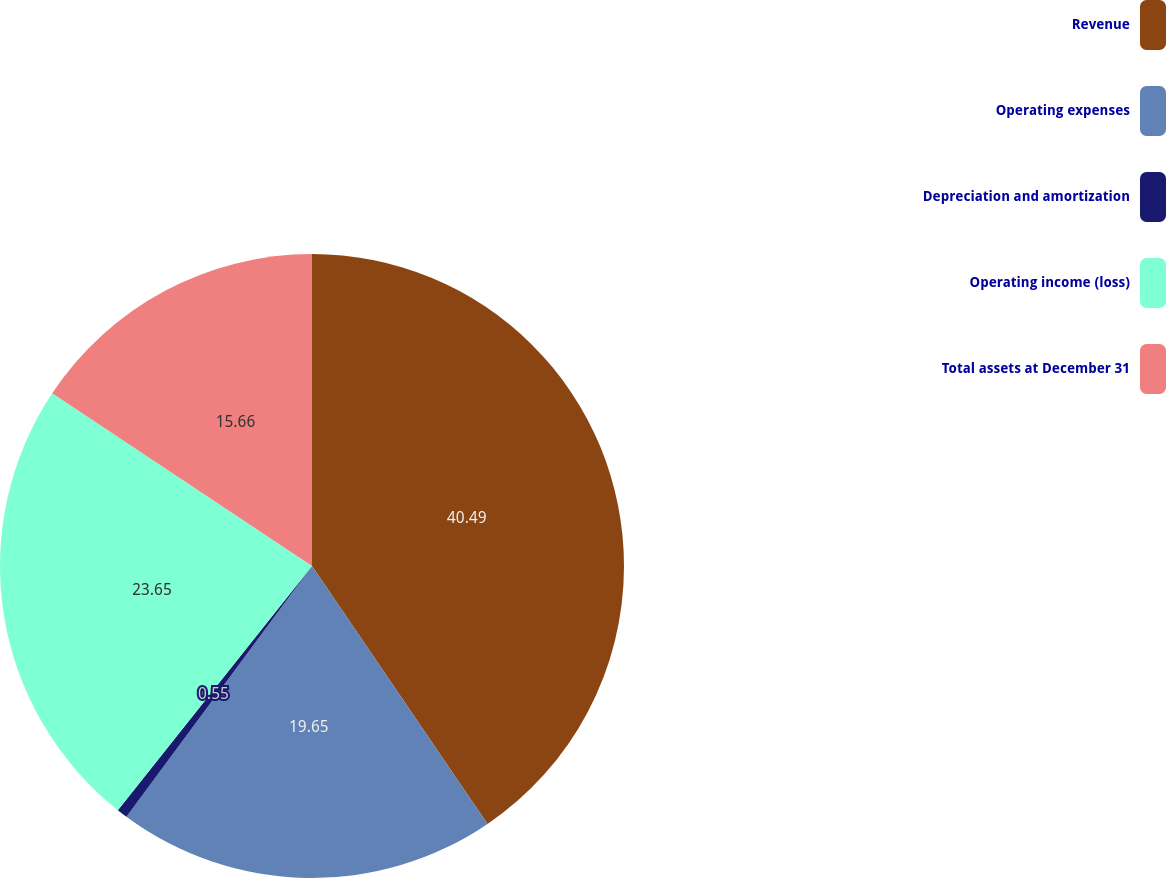Convert chart to OTSL. <chart><loc_0><loc_0><loc_500><loc_500><pie_chart><fcel>Revenue<fcel>Operating expenses<fcel>Depreciation and amortization<fcel>Operating income (loss)<fcel>Total assets at December 31<nl><fcel>40.49%<fcel>19.65%<fcel>0.55%<fcel>23.65%<fcel>15.66%<nl></chart> 